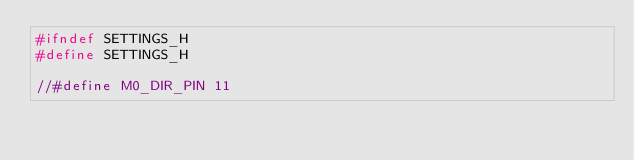<code> <loc_0><loc_0><loc_500><loc_500><_C_>#ifndef SETTINGS_H
#define SETTINGS_H

//#define M0_DIR_PIN 11</code> 